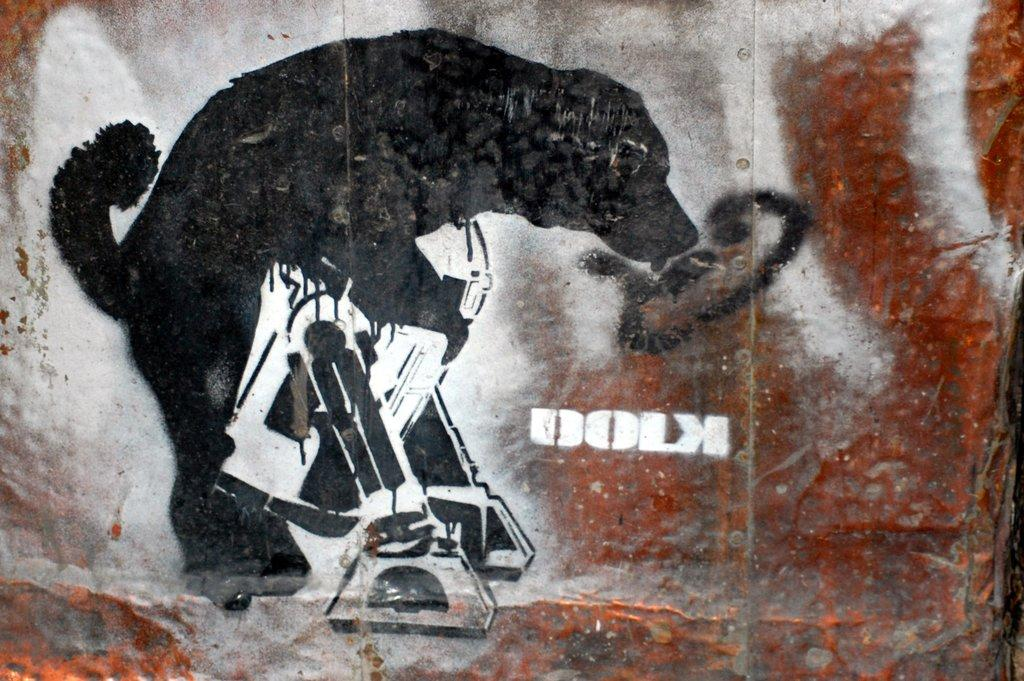What is depicted on the wall in the image? There is a painting of a dog on a wall. What color is the dog in the painting? The dog in the painting is black. What other colors are present in the painting? There are brown and white colors beside the dog in the painting. What type of game is the dog playing in the painting? There is no game being played in the painting; it is a static image of a dog. What is the dog using to iron its clothes in the painting? There is no iron or ironing activity depicted in the painting; it only shows a dog. 